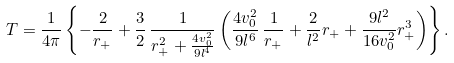Convert formula to latex. <formula><loc_0><loc_0><loc_500><loc_500>T = \frac { 1 } { 4 \pi } \left \{ - \frac { 2 } { r _ { + } } + \frac { 3 } { 2 } \, \frac { 1 } { r _ { + } ^ { 2 } + \frac { 4 v _ { 0 } ^ { 2 } } { 9 l ^ { 4 } } } \left ( \frac { 4 v _ { 0 } ^ { 2 } } { 9 l ^ { 6 } } \, \frac { 1 } { r _ { + } } + \frac { 2 } { l ^ { 2 } } r _ { + } + \frac { 9 l ^ { 2 } } { 1 6 v _ { 0 } ^ { 2 } } r _ { + } ^ { 3 } \right ) \right \} .</formula> 